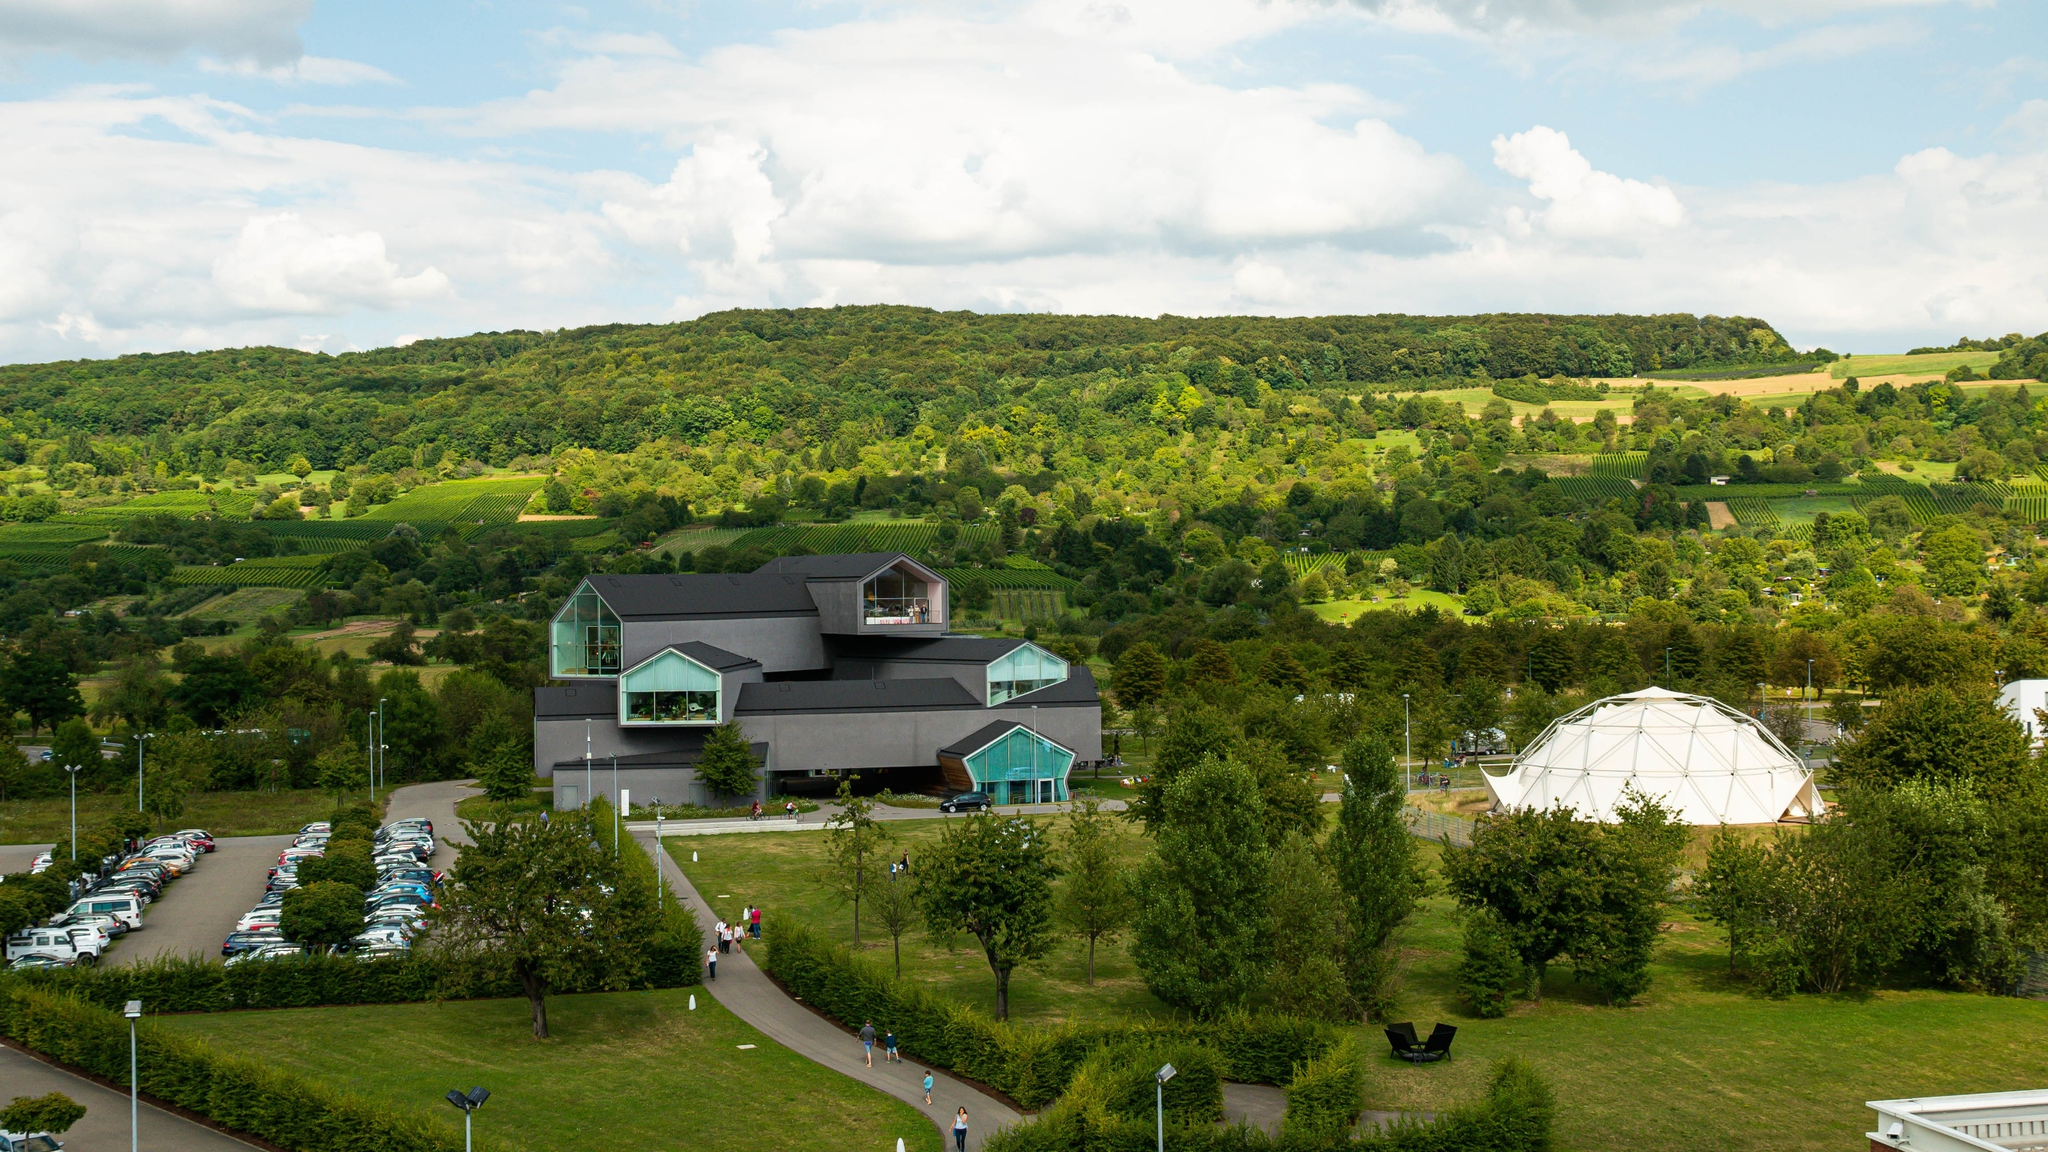Assume it is spring. Describe a family’s day out at the Vitra Design Museum. On a beautiful spring day, a family decides to visit the Vitra Design Museum. As they arrive, they are greeted by the vibrant greenery and colorful blossoms surrounding the contemporary black structure. The parking lot is busy, suggesting the museum is a popular spring destination. The family walks along the well-manicured pathways, taking in the stunning view of the rolling hills and vibrant landscape. Inside, they explore various exhibits, intrigued by the blend of art and design on display. After spending a few hours inside, they enjoy a picnic on the museum’s grassy lawns, surrounded by the sights and sounds of nature coming to life. The children play near the adjacent geodesic dome while the parents relax, absorbing the tranquil beauty of their surroundings. It’s a harmonious blend of cultural enrichment and nature’s splendor, creating cherished memories for the family. 